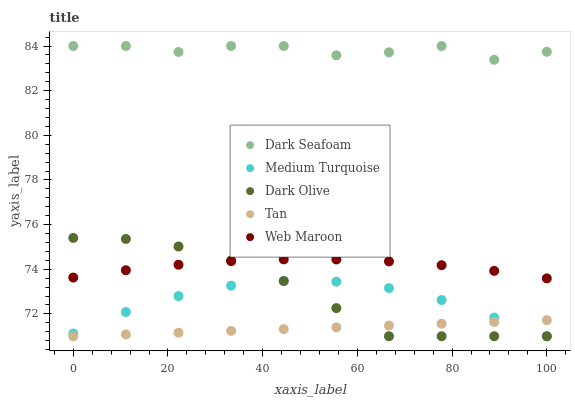Does Tan have the minimum area under the curve?
Answer yes or no. Yes. Does Dark Seafoam have the maximum area under the curve?
Answer yes or no. Yes. Does Dark Olive have the minimum area under the curve?
Answer yes or no. No. Does Dark Olive have the maximum area under the curve?
Answer yes or no. No. Is Tan the smoothest?
Answer yes or no. Yes. Is Dark Seafoam the roughest?
Answer yes or no. Yes. Is Dark Olive the smoothest?
Answer yes or no. No. Is Dark Olive the roughest?
Answer yes or no. No. Does Dark Olive have the lowest value?
Answer yes or no. Yes. Does Web Maroon have the lowest value?
Answer yes or no. No. Does Dark Seafoam have the highest value?
Answer yes or no. Yes. Does Dark Olive have the highest value?
Answer yes or no. No. Is Medium Turquoise less than Dark Seafoam?
Answer yes or no. Yes. Is Web Maroon greater than Tan?
Answer yes or no. Yes. Does Web Maroon intersect Dark Olive?
Answer yes or no. Yes. Is Web Maroon less than Dark Olive?
Answer yes or no. No. Is Web Maroon greater than Dark Olive?
Answer yes or no. No. Does Medium Turquoise intersect Dark Seafoam?
Answer yes or no. No. 